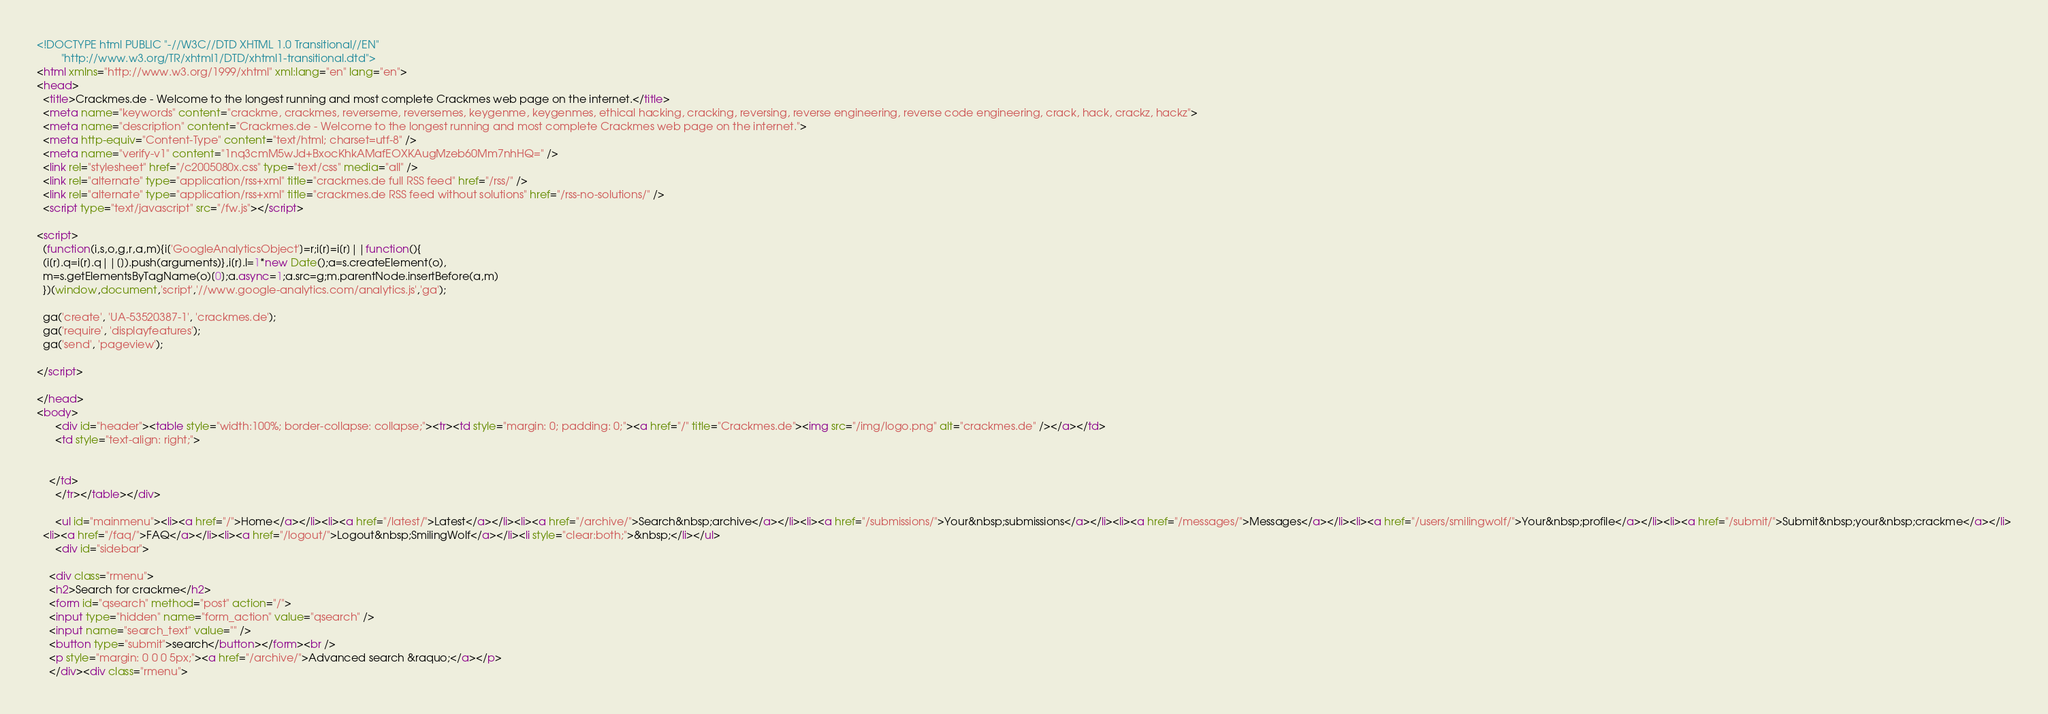Convert code to text. <code><loc_0><loc_0><loc_500><loc_500><_HTML_><!DOCTYPE html PUBLIC "-//W3C//DTD XHTML 1.0 Transitional//EN"
        "http://www.w3.org/TR/xhtml1/DTD/xhtml1-transitional.dtd">
<html xmlns="http://www.w3.org/1999/xhtml" xml:lang="en" lang="en">
<head>
  <title>Crackmes.de - Welcome to the longest running and most complete Crackmes web page on the internet.</title>
  <meta name="keywords" content="crackme, crackmes, reverseme, reversemes, keygenme, keygenmes, ethical hacking, cracking, reversing, reverse engineering, reverse code engineering, crack, hack, crackz, hackz">
  <meta name="description" content="Crackmes.de - Welcome to the longest running and most complete Crackmes web page on the internet.">
  <meta http-equiv="Content-Type" content="text/html; charset=utf-8" />
  <meta name="verify-v1" content="1nq3cmM5wJd+BxocKhkAMafEOXKAugMzeb60Mm7nhHQ=" />
  <link rel="stylesheet" href="/c2005080x.css" type="text/css" media="all" />
  <link rel="alternate" type="application/rss+xml" title="crackmes.de full RSS feed" href="/rss/" />
  <link rel="alternate" type="application/rss+xml" title="crackmes.de RSS feed without solutions" href="/rss-no-solutions/" />
  <script type="text/javascript" src="/fw.js"></script>

<script>
  (function(i,s,o,g,r,a,m){i['GoogleAnalyticsObject']=r;i[r]=i[r]||function(){
  (i[r].q=i[r].q||[]).push(arguments)},i[r].l=1*new Date();a=s.createElement(o),
  m=s.getElementsByTagName(o)[0];a.async=1;a.src=g;m.parentNode.insertBefore(a,m)
  })(window,document,'script','//www.google-analytics.com/analytics.js','ga');

  ga('create', 'UA-53520387-1', 'crackmes.de');
  ga('require', 'displayfeatures');
  ga('send', 'pageview');

</script>

</head>
<body>
      <div id="header"><table style="width:100%; border-collapse: collapse;"><tr><td style="margin: 0; padding: 0;"><a href="/" title="Crackmes.de"><img src="/img/logo.png" alt="crackmes.de" /></a></td>
      <td style="text-align: right;">


	</td>
      </tr></table></div>

      <ul id="mainmenu"><li><a href="/">Home</a></li><li><a href="/latest/">Latest</a></li><li><a href="/archive/">Search&nbsp;archive</a></li><li><a href="/submissions/">Your&nbsp;submissions</a></li><li><a href="/messages/">Messages</a></li><li><a href="/users/smilingwolf/">Your&nbsp;profile</a></li><li><a href="/submit/">Submit&nbsp;your&nbsp;crackme</a></li>
  <li><a href="/faq/">FAQ</a></li><li><a href="/logout/">Logout&nbsp;SmilingWolf</a></li><li style="clear:both;">&nbsp;</li></ul>
      <div id="sidebar">
      
    <div class="rmenu">
    <h2>Search for crackme</h2>
    <form id="qsearch" method="post" action="/">
    <input type="hidden" name="form_action" value="qsearch" />
    <input name="search_text" value="" />
    <button type="submit">search</button></form><br />
    <p style="margin: 0 0 0 5px;"><a href="/archive/">Advanced search &raquo;</a></p>
    </div><div class="rmenu"></code> 